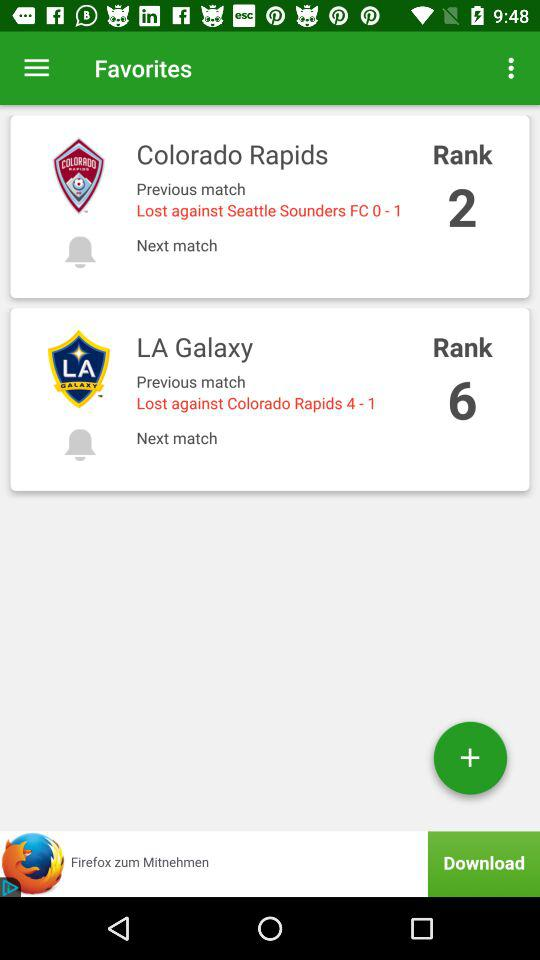What is the rank of "Colorado Rapids"? The rank is 2. 